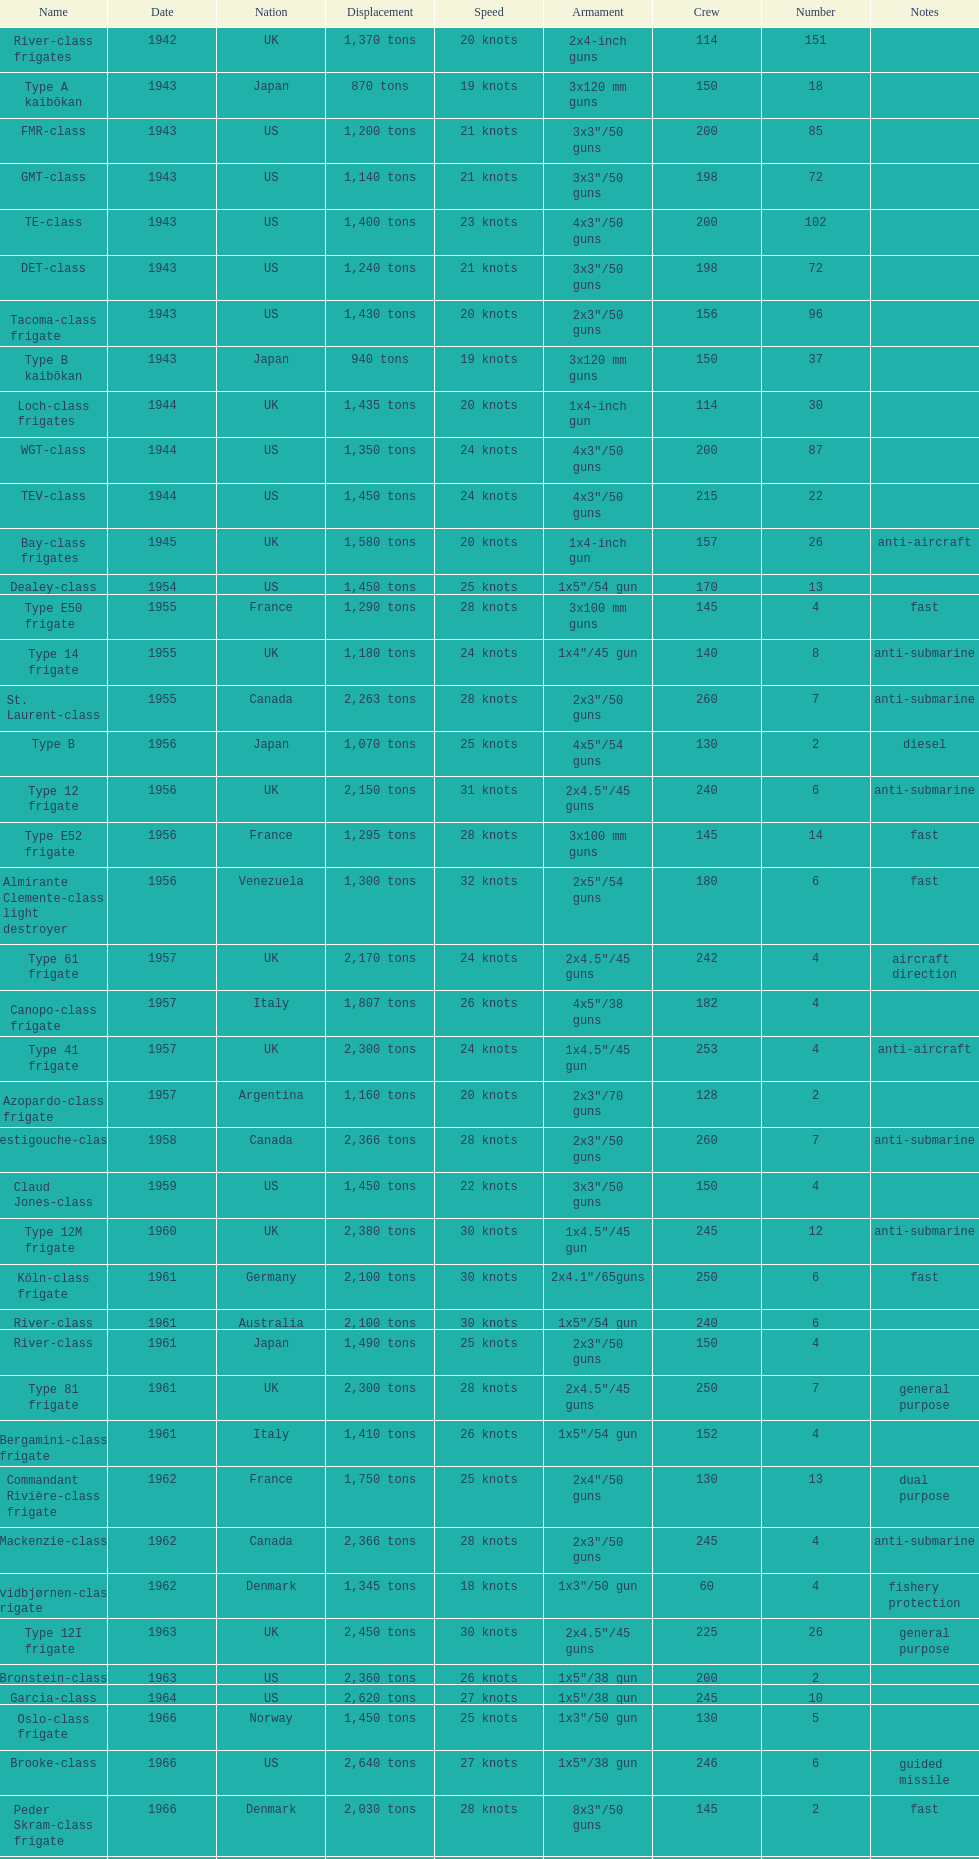What is the amount of displacement in tons for type b? 940 tons. 